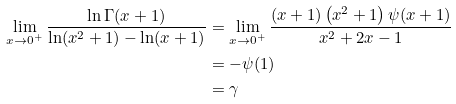Convert formula to latex. <formula><loc_0><loc_0><loc_500><loc_500>\lim _ { x \to 0 ^ { + } } \frac { \ln \Gamma ( x + 1 ) } { \ln ( x ^ { 2 } + 1 ) - \ln ( x + 1 ) } & = \lim _ { x \to 0 ^ { + } } \frac { ( x + 1 ) \left ( x ^ { 2 } + 1 \right ) \psi ( x + 1 ) } { x ^ { 2 } + 2 x - 1 } \\ & = - \psi ( 1 ) \\ & = \gamma</formula> 